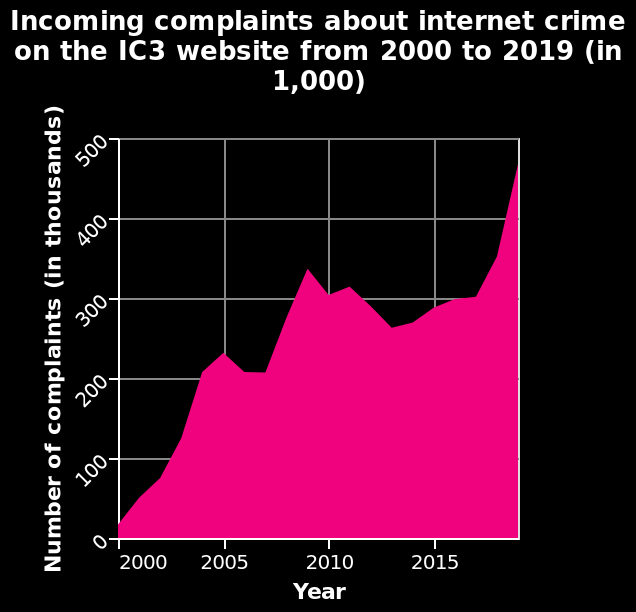<image>
What was the number of complaints about internet crime in 2019?  In 2019, the number of complaints about internet crime had risen to nearly 500,000. What does the chart show about the number of complaints about internet crime on the IC3 website?  The chart shows that the number of complaints about internet crime on the IC3 website has increased significantly between 2000 and 2019. 